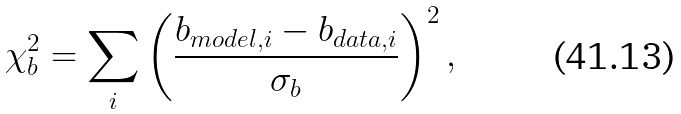<formula> <loc_0><loc_0><loc_500><loc_500>\chi ^ { 2 } _ { b } = \sum _ { i } \left ( \frac { b _ { m o d e l , i } - b _ { d a t a , i } } { \sigma _ { b } } \right ) ^ { 2 } ,</formula> 